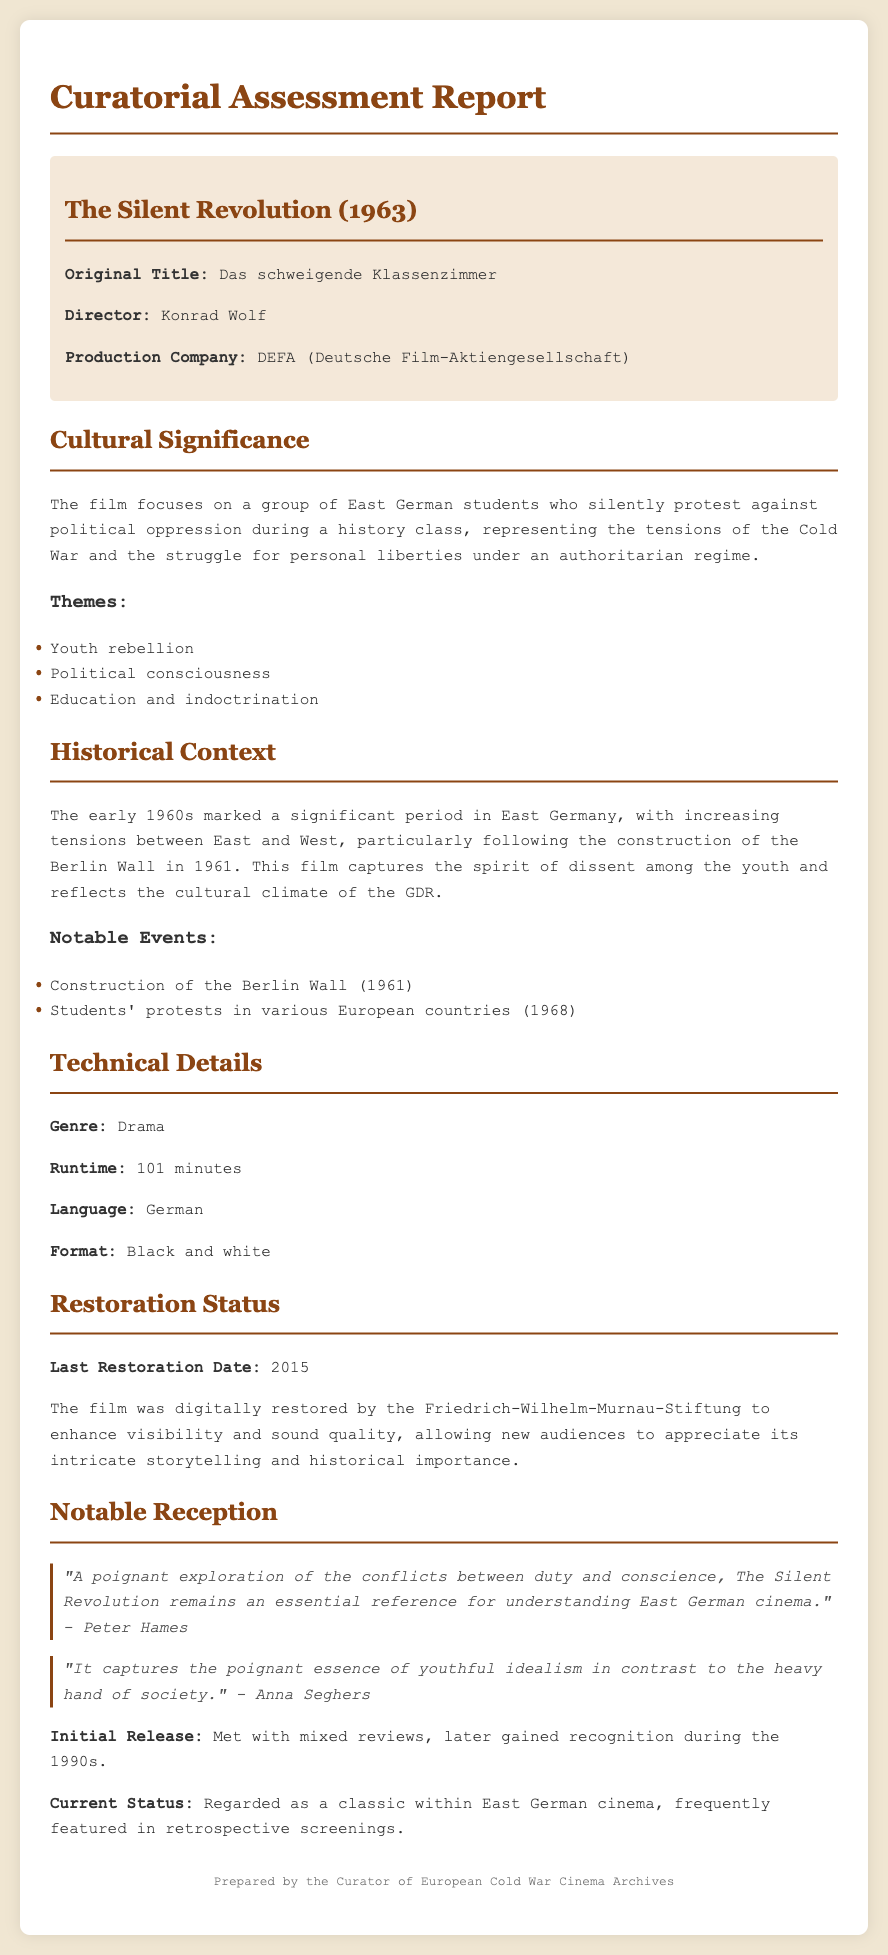What is the original title of the film? The original title is mentioned in the film information section of the document.
Answer: Das schweigende Klassenzimmer Who directed The Silent Revolution? The director's name is specified in the film information section of the document.
Answer: Konrad Wolf What year was the film released? The release year can be found in the report header.
Answer: 1963 What is the runtime of the film? The runtime is specified under the technical details section of the document.
Answer: 101 minutes What major historical event is mentioned in relation to the film's context? Notable events related to the film's historical context are listed in the document.
Answer: Construction of the Berlin Wall What organization restored the film? The restoration status section states the organization that carried out the restoration.
Answer: Friedrich-Wilhelm-Murnau-Stiftung What genre does the film belong to? The genre is specified under the technical details part of the document.
Answer: Drama Which themes are explored in The Silent Revolution? The themes are mentioned under the cultural significance section of the document.
Answer: Youth rebellion, Political consciousness, Education and indoctrination What is the status of the film’s reception? The current status of the film is described in the reception section.
Answer: Regarded as a classic within East German cinema 